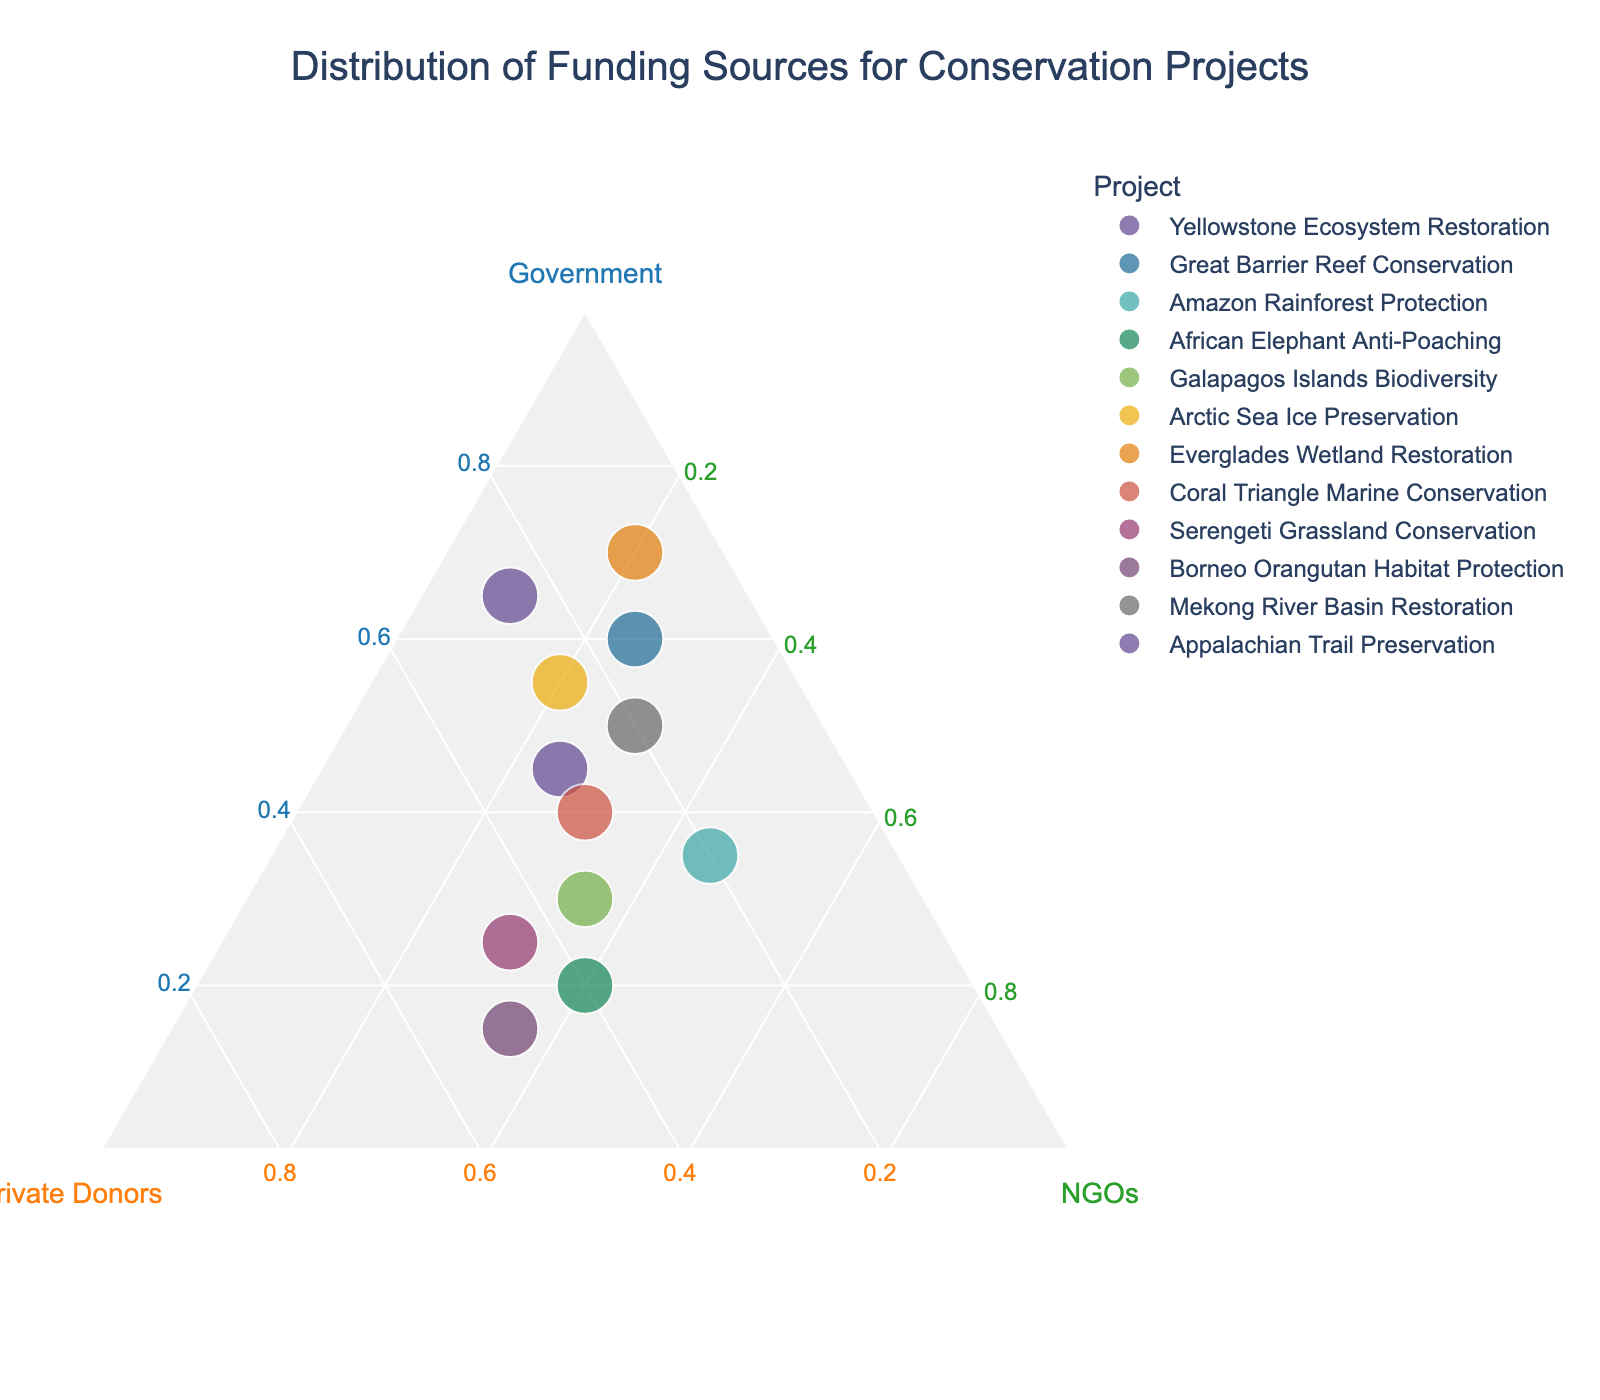What's the title of the ternary plot? The title of the plot is usually displayed at the top of the figure. In this case, the title is provided in the code as "Distribution of Funding Sources for Conservation Projects"
Answer: Distribution of Funding Sources for Conservation Projects What are the three funding sources represented by the axes in the ternary plot? Ternary plots have three axes. In this figure, the axes are labeled with the funding sources: "Government," "Private Donors," and "NGOs".
Answer: Government, Private Donors, NGOs How many conservation projects are represented in the plot? The number of conservation projects represented corresponds to the number of data points, which is the number of rows in the dataset minus the header row. There are 12 projects listed.
Answer: 12 Which conservation project has the largest percentage of government funding? Each data point's position indicates the percentage of funding from each source. The Everglades Wetland Restoration project is closest to the "Government" axis, indicating it has the highest government funding percentage.
Answer: Everglades Wetland Restoration What percentage of total funding comes from NGOs for the Amazon Rainforest Protection project? By locating the Amazon Rainforest Protection project on the plot and looking at its position relative to the NGOs axis, the percentage can be estimated from the ternary plot. According to the data, it's 45%.
Answer: 45% Which two projects have an equal percentage contribution from NGOs but differing contributions from other sources? By inspecting the plot and locating points that line up vertically on the "NGOs" axis, both African Elephant Anti-Poaching and Galapagos Islands Biodiversity have an equal percentage (40%) contribution from NGOs.
Answer: African Elephant Anti-Poaching, Galapagos Islands Biodiversity Compare the funding distribution of the Serengeti Grassland Conservation project to the Borneo Orangutan Habitat Protection project. Which has a higher percentage from Private Donors? By comparing their positions on the ternary plot, Serengeti Grassland Conservation (45%) has a higher percentage from Private Donors than Borneo Orangutan Habitat Protection (50%).
Answer: Borneo Orangutan Habitat Protection What project lies closest to the center of the ternary plot, and why does this matter? The project closest to the center will have relatively balanced funding from all three sources. According to the plot, Coral Triangle Marine Conservation lies near the center, showing a balanced distribution among Government, Private Donors, and NGOs.
Answer: Coral Triangle Marine Conservation What is the average percentage contribution from Private Donors across all projects? To find the average, sum the percentages from Private Donors for all projects and divide by the number of projects (sum of [30, 15, 20, 40, 35, 25, 10, 30, 45, 50, 20, 25] divided by 12 results in 30.8%).
Answer: 30.8% Identify a project with a high percentage of funding from NGOs and discuss its importance. A project with a high percentage of NGO funding can be found by locating points close to the "NGOs" axis. The Amazon Rainforest Protection project has 45% funding from NGOs. This high NGO contribution implies that non-governmental organizations play a crucial role in its funding, reflecting the international environment and biodiversity importance.
Answer: Amazon Rainforest Protection 